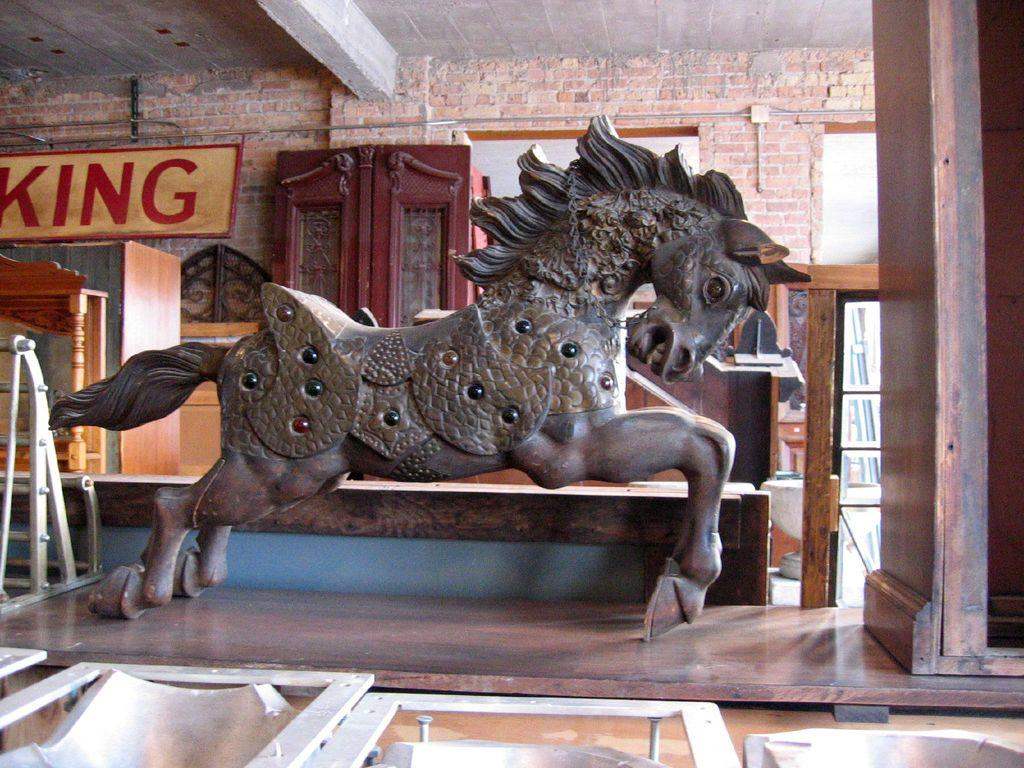What is the main subject of the image? There is a sculpture in the image. What can be seen in the background of the image? There are objects and a hoarding in the background of the image. What type of magic is being performed by the sculpture in the image? There is no magic being performed by the sculpture in the image; it is a static object. 